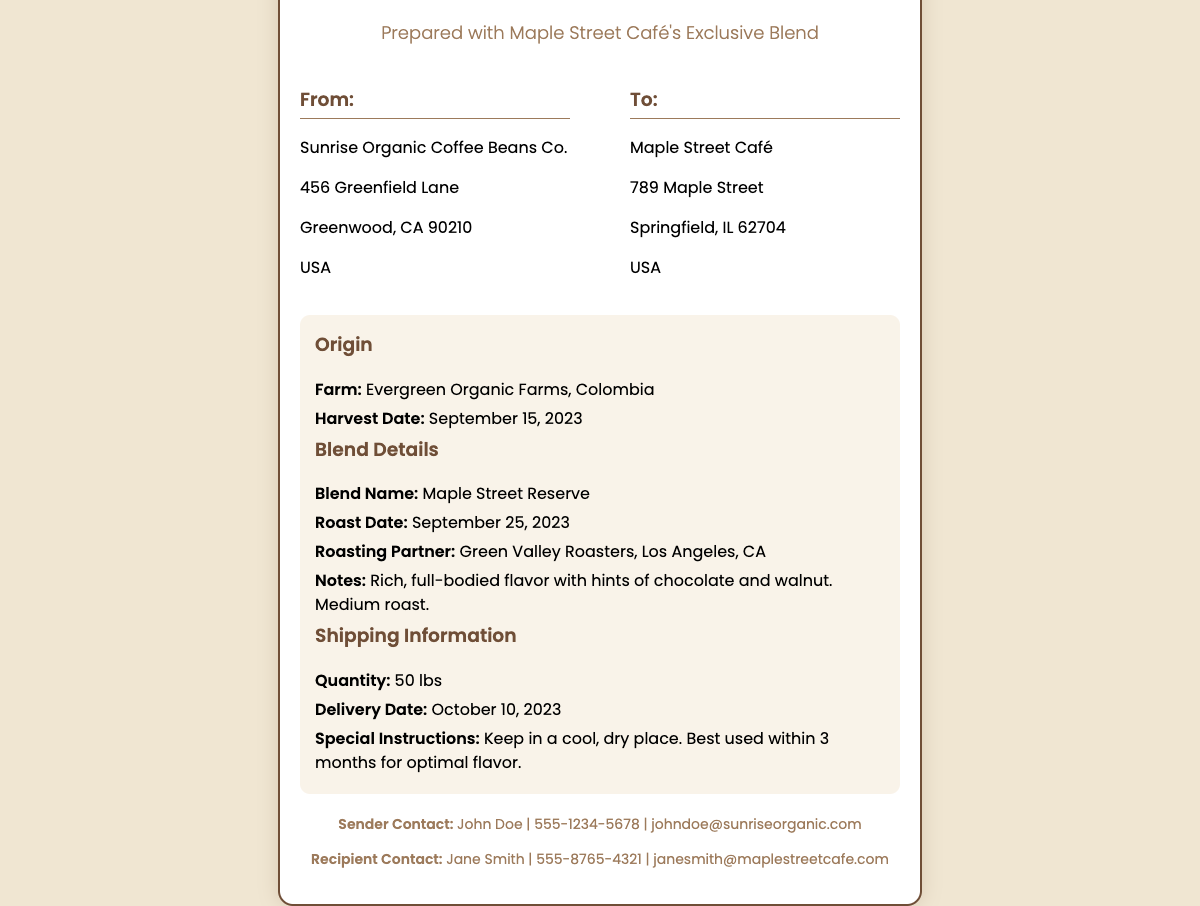What is the name of the sender? The sender's name is listed at the bottom of the document.
Answer: John Doe What is the delivery date? The document states the specific delivery date under shipping information.
Answer: October 10, 2023 Which café is receiving the coffee beans? The recipient's name is mentioned in the "To" section of the address.
Answer: Maple Street Café What is the quantity of coffee beans being shipped? The quantity is specified in the shipping information section of the document.
Answer: 50 lbs What is the harvest date of the coffee beans? The harvest date is mentioned in the details section under origin.
Answer: September 15, 2023 Who is the roasting partner? The roasting partner's name is provided in the blend details section.
Answer: Green Valley Roasters What should be done with the beans for optimal flavor? Special instructions detail how to store the beans for best use.
Answer: Keep in a cool, dry place What type of roast is the coffee blend? The roast type is described in the blend details section.
Answer: Medium roast What origin farm is mentioned for the coffee beans? The document specifies the farm that sourced the coffee beans under the origin section.
Answer: Evergreen Organic Farms, Colombia 